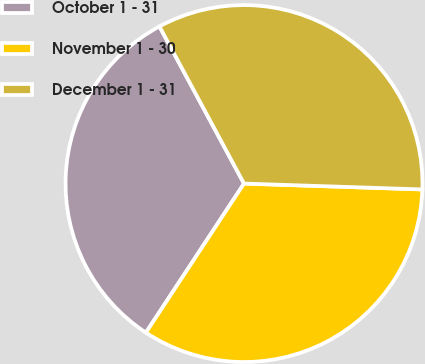Convert chart. <chart><loc_0><loc_0><loc_500><loc_500><pie_chart><fcel>October 1 - 31<fcel>November 1 - 30<fcel>December 1 - 31<nl><fcel>32.88%<fcel>33.74%<fcel>33.38%<nl></chart> 